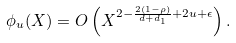Convert formula to latex. <formula><loc_0><loc_0><loc_500><loc_500>\phi _ { u } ( X ) = O \left ( X ^ { 2 - \frac { 2 ( 1 - \rho ) } { d + d _ { 1 } } + 2 u + \epsilon } \right ) .</formula> 